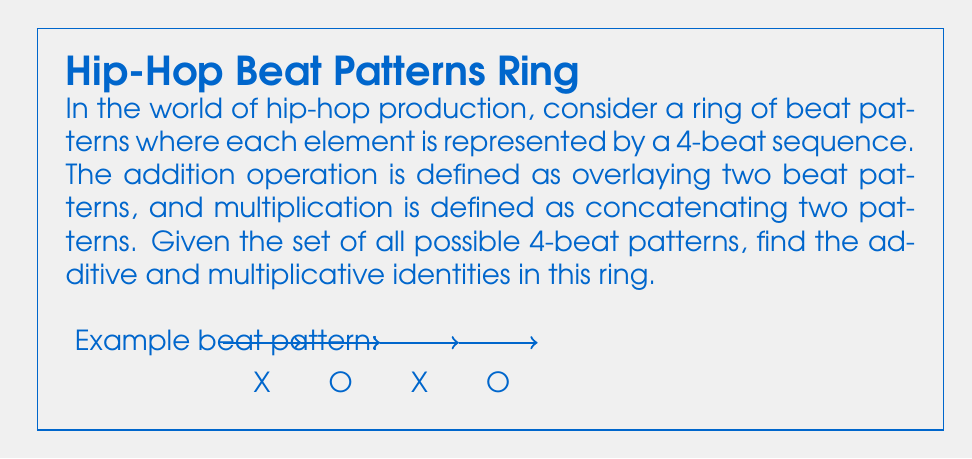Can you solve this math problem? Let's approach this step-by-step:

1) Additive Identity:
   - In ring theory, the additive identity is an element that, when added to any other element, leaves that element unchanged.
   - In our beat pattern ring, addition is defined as overlaying patterns.
   - The additive identity would be a pattern that, when overlaid on any other pattern, doesn't change it.
   - This would be represented by a silent 4-beat pattern: $$(O,O,O,O)$$
   - When overlaid on any other pattern, it adds no sound, thus leaving the original pattern unchanged.

2) Multiplicative Identity:
   - The multiplicative identity is an element that, when multiplied by any other element, leaves that element unchanged.
   - In our ring, multiplication is defined as concatenation.
   - The multiplicative identity would need to be a pattern that, when concatenated with any other pattern, doesn't change the original pattern.
   - This is represented by an empty pattern: $$()$$
   - When concatenated with any 4-beat pattern, it adds no additional beats, thus leaving the original pattern unchanged.

3) Verification:
   - For any beat pattern $a$:
     Additive: $a + (O,O,O,O) = a$
     Multiplicative: $a \cdot () = () \cdot a = a$

These identities satisfy the ring axioms for our hip-hop beat pattern ring.
Answer: Additive identity: $(O,O,O,O)$, Multiplicative identity: $()$ 